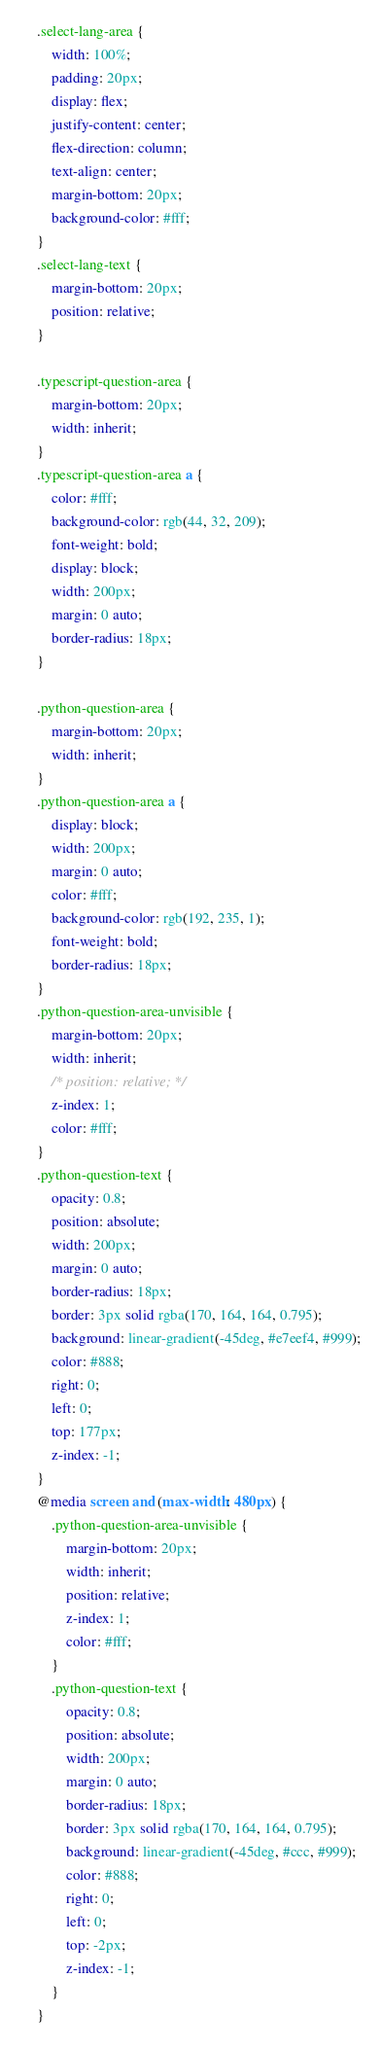<code> <loc_0><loc_0><loc_500><loc_500><_CSS_>.select-lang-area {
    width: 100%;
    padding: 20px;
    display: flex;
    justify-content: center;
    flex-direction: column;
    text-align: center;
    margin-bottom: 20px;
    background-color: #fff;
}
.select-lang-text {
    margin-bottom: 20px;
    position: relative;
}

.typescript-question-area {
    margin-bottom: 20px;
    width: inherit;
}
.typescript-question-area a {
    color: #fff;
    background-color: rgb(44, 32, 209);
    font-weight: bold;
    display: block;
    width: 200px;
    margin: 0 auto;
    border-radius: 18px;
}

.python-question-area {
    margin-bottom: 20px;
    width: inherit;
}
.python-question-area a {
    display: block;
    width: 200px;
    margin: 0 auto;
    color: #fff;
    background-color: rgb(192, 235, 1);
    font-weight: bold;
    border-radius: 18px;
}
.python-question-area-unvisible {
    margin-bottom: 20px;
    width: inherit;
    /* position: relative; */
    z-index: 1;
    color: #fff;
}
.python-question-text {
    opacity: 0.8;
    position: absolute;
    width: 200px;
    margin: 0 auto;
    border-radius: 18px;
    border: 3px solid rgba(170, 164, 164, 0.795);
    background: linear-gradient(-45deg, #e7eef4, #999);
    color: #888;
    right: 0;
    left: 0;
    top: 177px;
    z-index: -1;
}
@media screen and (max-width: 480px) {
    .python-question-area-unvisible {
        margin-bottom: 20px;
        width: inherit;
        position: relative;
        z-index: 1;
        color: #fff;
    }
    .python-question-text {
        opacity: 0.8;
        position: absolute;
        width: 200px;
        margin: 0 auto;
        border-radius: 18px;
        border: 3px solid rgba(170, 164, 164, 0.795);
        background: linear-gradient(-45deg, #ccc, #999);
        color: #888;
        right: 0;
        left: 0;
        top: -2px;
        z-index: -1;
    }
}
</code> 